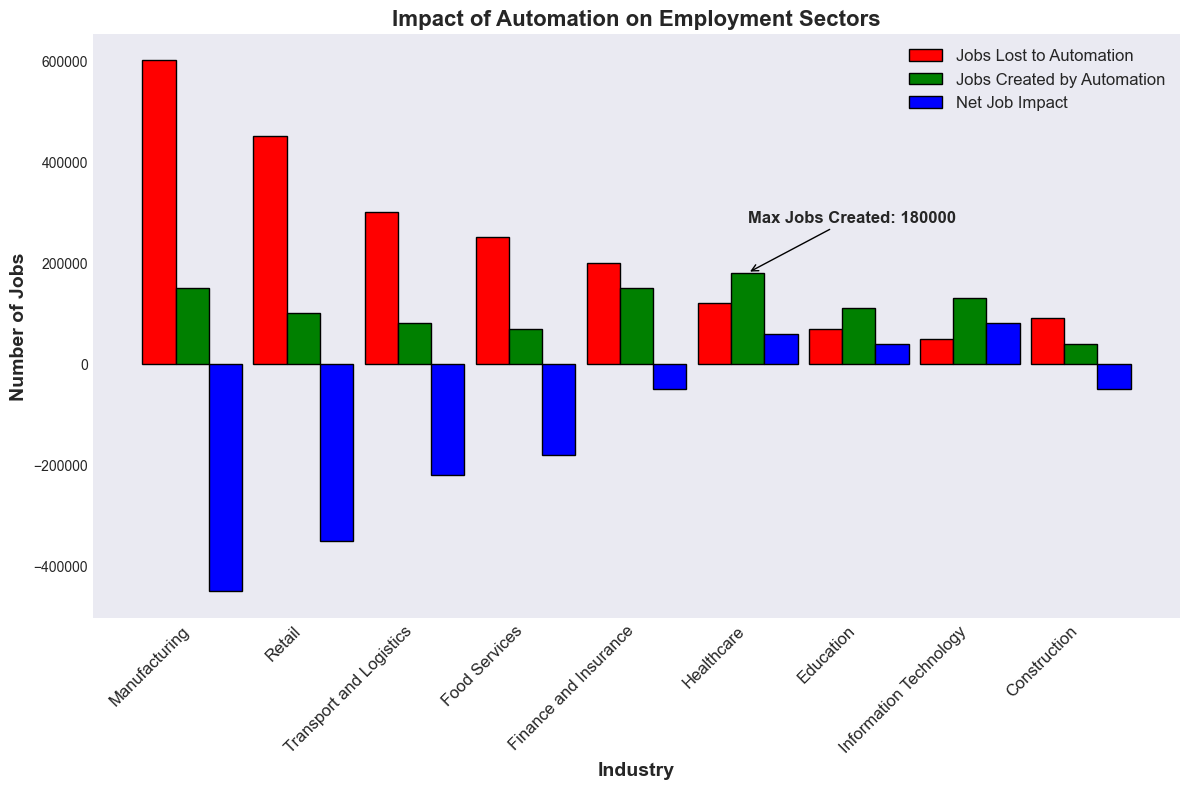What is the total number of jobs lost to automation across all industries? To calculate the total number of jobs lost to automation, sum the jobs lost in each industry: 600,000 (Manufacturing) + 450,000 (Retail) + 300,000 (Transport and Logistics) + 250,000 (Food Services) + 200,000 (Finance and Insurance) + 120,000 (Healthcare) + 70,000 (Education) + 50,000 (Information Technology) + 90,000 (Construction) = 2,130,000
Answer: 2,130,000 Which industry has the highest net job impact? Review the net job impact values for each industry. Information Technology has the highest net job impact of 80,000
Answer: Information Technology How does the number of jobs lost compare to the number of jobs created in the retail industry? In the retail industry, jobs lost are 450,000 and jobs created are 100,000. 450,000 (jobs lost) is greater than 100,000 (jobs created)
Answer: Jobs lost are greater What is the net job impact in the manufacturing industry? The net job impact in the manufacturing industry is given directly as -450,000
Answer: -450,000 Which industry has the highest number of jobs created by automation, and what is that number? The industry with the highest number of jobs created by automation is Healthcare, which created 180,000 jobs, as indicated by the annotation on the chart
Answer: Healthcare Compare the net job impact of the finance and insurance industry to the net job impact of the construction industry. Which one is larger? Net job impact in Finance and Insurance is -50,000, and in Construction, it is also -50,000. Thus, they are equal
Answer: Equal How many more jobs were lost than created in the food services industry? Jobs lost in food services is 250,000, and jobs created is 70,000. The difference is 250,000 - 70,000 = 180,000
Answer: 180,000 What is the average net job impact across all industries? Sum the net job impacts and divide by the number of industries: (-450,000) + (-350,000) + (-220,000) + (-180,000) + (-50,000) + 60,000 + 40,000 + 80,000 + (-50,000) = -1,120,000. There are 9 industries, so -1,120,000 / 9 = -124,444.44
Answer: -124,444.44 What is the difference between the highest and lowest net job impacts? The highest net job impact is 80,000 (Information Technology), and the lowest is -450,000 (Manufacturing). The difference is 450,000 (absolute value of the lowest) - 80,000 = 370,000
Answer: 370,000 